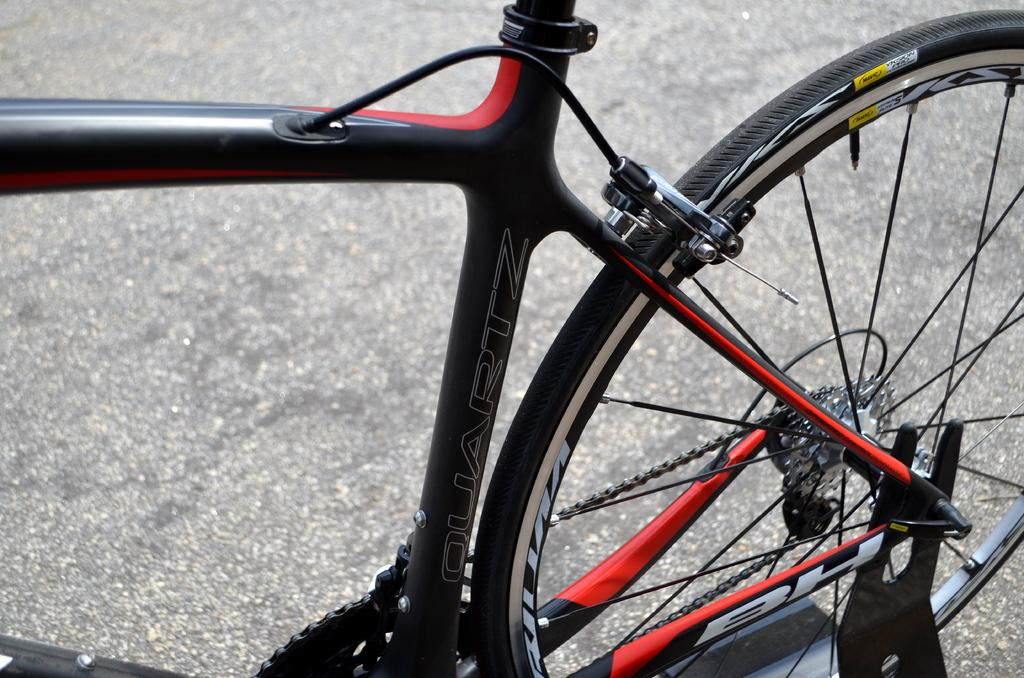What is the main object in the image? There is a bicycle in the image. How is the bicycle depicted in the image? The bicycle appears to be truncated or partially visible. What type of surface can be seen in the image? There is a road in the image. How many iron deer are present on the road in the image? There are no iron deer present in the image; it only features a bicycle and a road. 